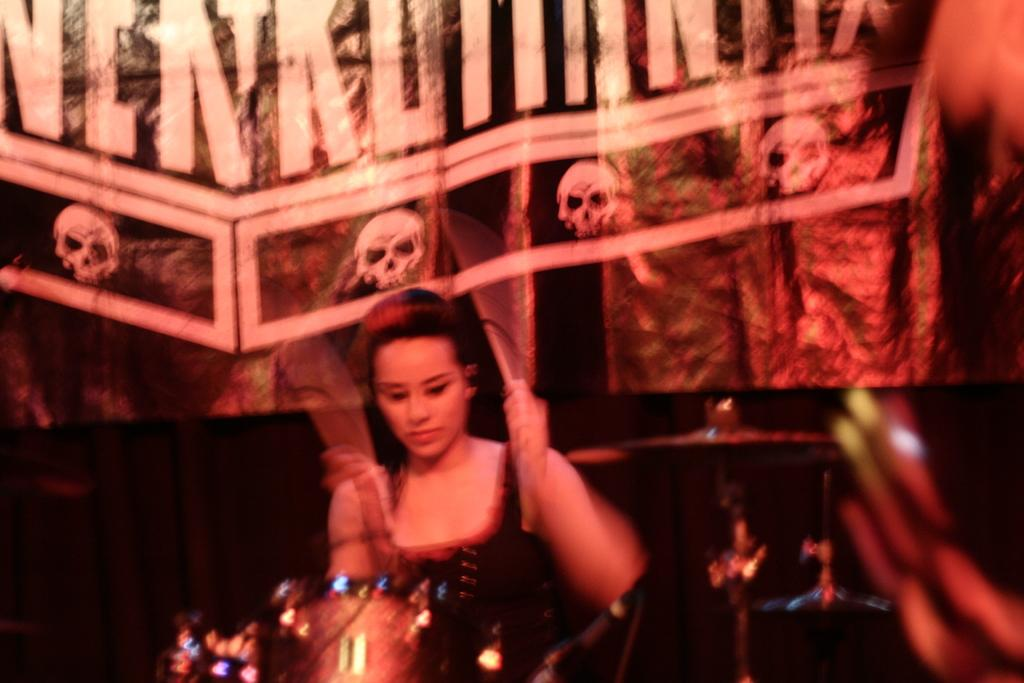Who is the main subject in the image? There is a woman in the image. What is the woman doing in the image? The woman is playing a musical instrument. What can be seen in the background of the image? There are posters in the background of the image. What is the weight of the branch visible in the image? There is no branch present in the image. How many floors can be seen in the image? The image does not show any floors, as it is focused on the woman playing a musical instrument and the background with posters. 